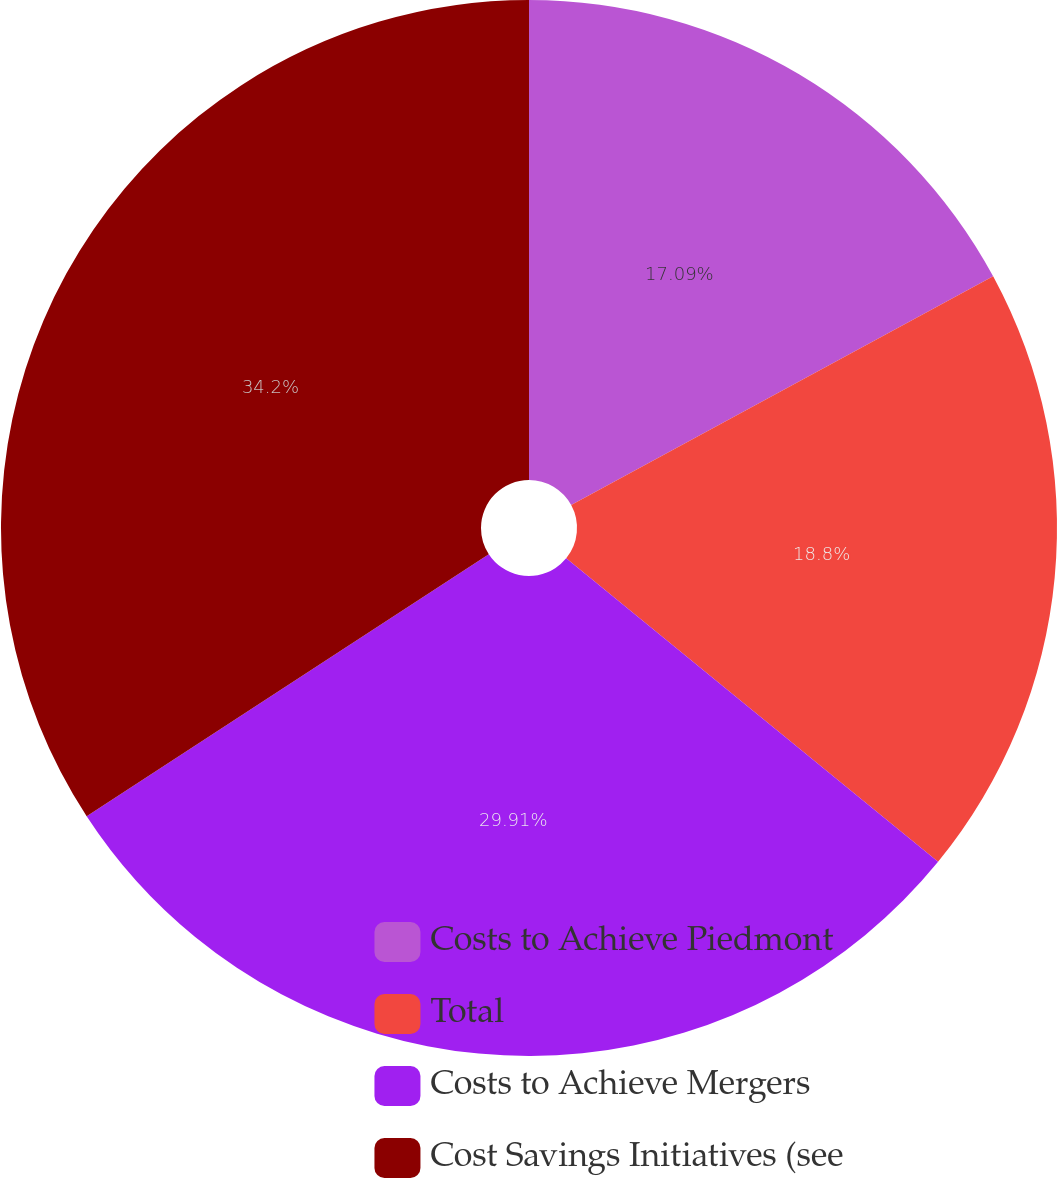Convert chart. <chart><loc_0><loc_0><loc_500><loc_500><pie_chart><fcel>Costs to Achieve Piedmont<fcel>Total<fcel>Costs to Achieve Mergers<fcel>Cost Savings Initiatives (see<nl><fcel>17.09%<fcel>18.8%<fcel>29.91%<fcel>34.19%<nl></chart> 